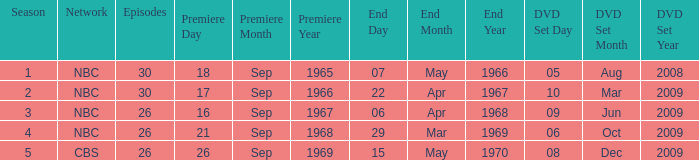When dis cbs release the DVD set? 08-Dec-2009. 